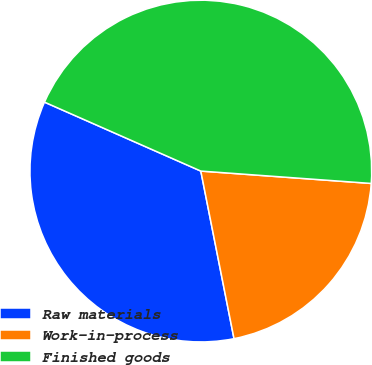Convert chart to OTSL. <chart><loc_0><loc_0><loc_500><loc_500><pie_chart><fcel>Raw materials<fcel>Work-in-process<fcel>Finished goods<nl><fcel>34.72%<fcel>20.73%<fcel>44.54%<nl></chart> 